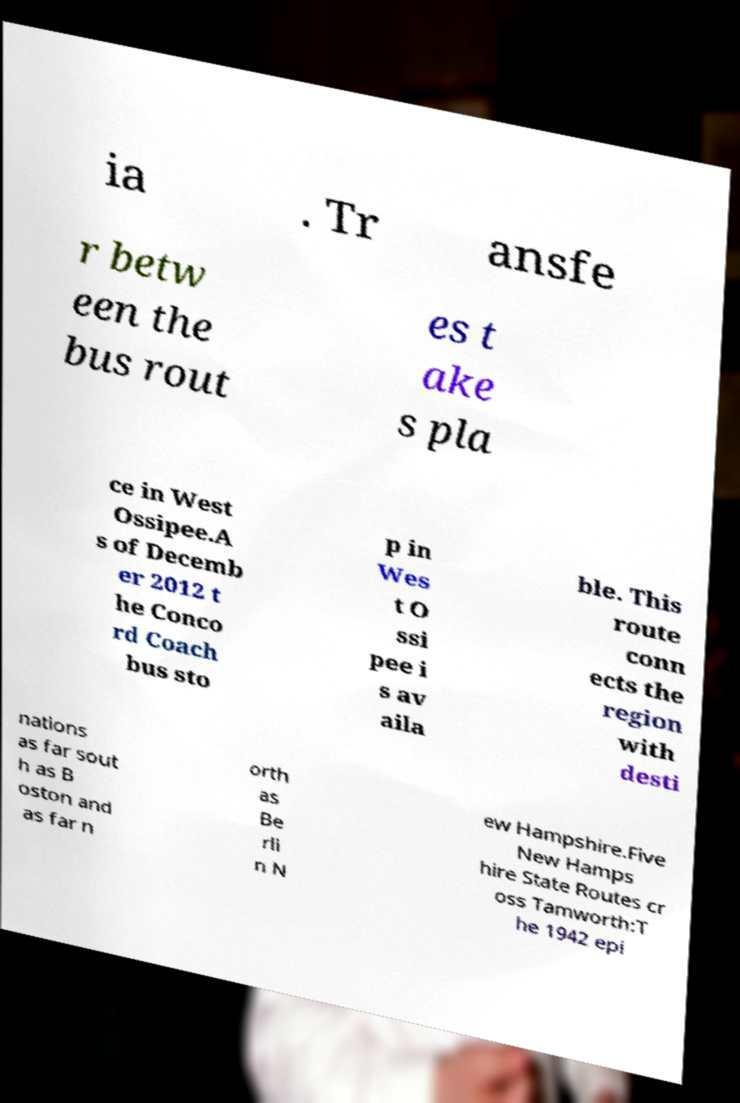There's text embedded in this image that I need extracted. Can you transcribe it verbatim? ia . Tr ansfe r betw een the bus rout es t ake s pla ce in West Ossipee.A s of Decemb er 2012 t he Conco rd Coach bus sto p in Wes t O ssi pee i s av aila ble. This route conn ects the region with desti nations as far sout h as B oston and as far n orth as Be rli n N ew Hampshire.Five New Hamps hire State Routes cr oss Tamworth:T he 1942 epi 